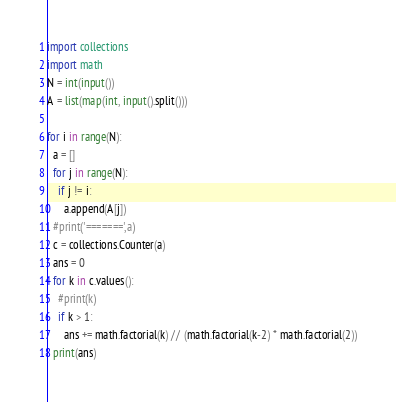<code> <loc_0><loc_0><loc_500><loc_500><_Python_>import collections
import math
N = int(input())
A = list(map(int, input().split()))

for i in range(N):
  a = []
  for j in range(N):
    if j != i:
      a.append(A[j])
  #print('=======',a)
  c = collections.Counter(a)
  ans = 0
  for k in c.values():
    #print(k)
    if k > 1:
      ans += math.factorial(k) // (math.factorial(k-2) * math.factorial(2))
  print(ans)</code> 